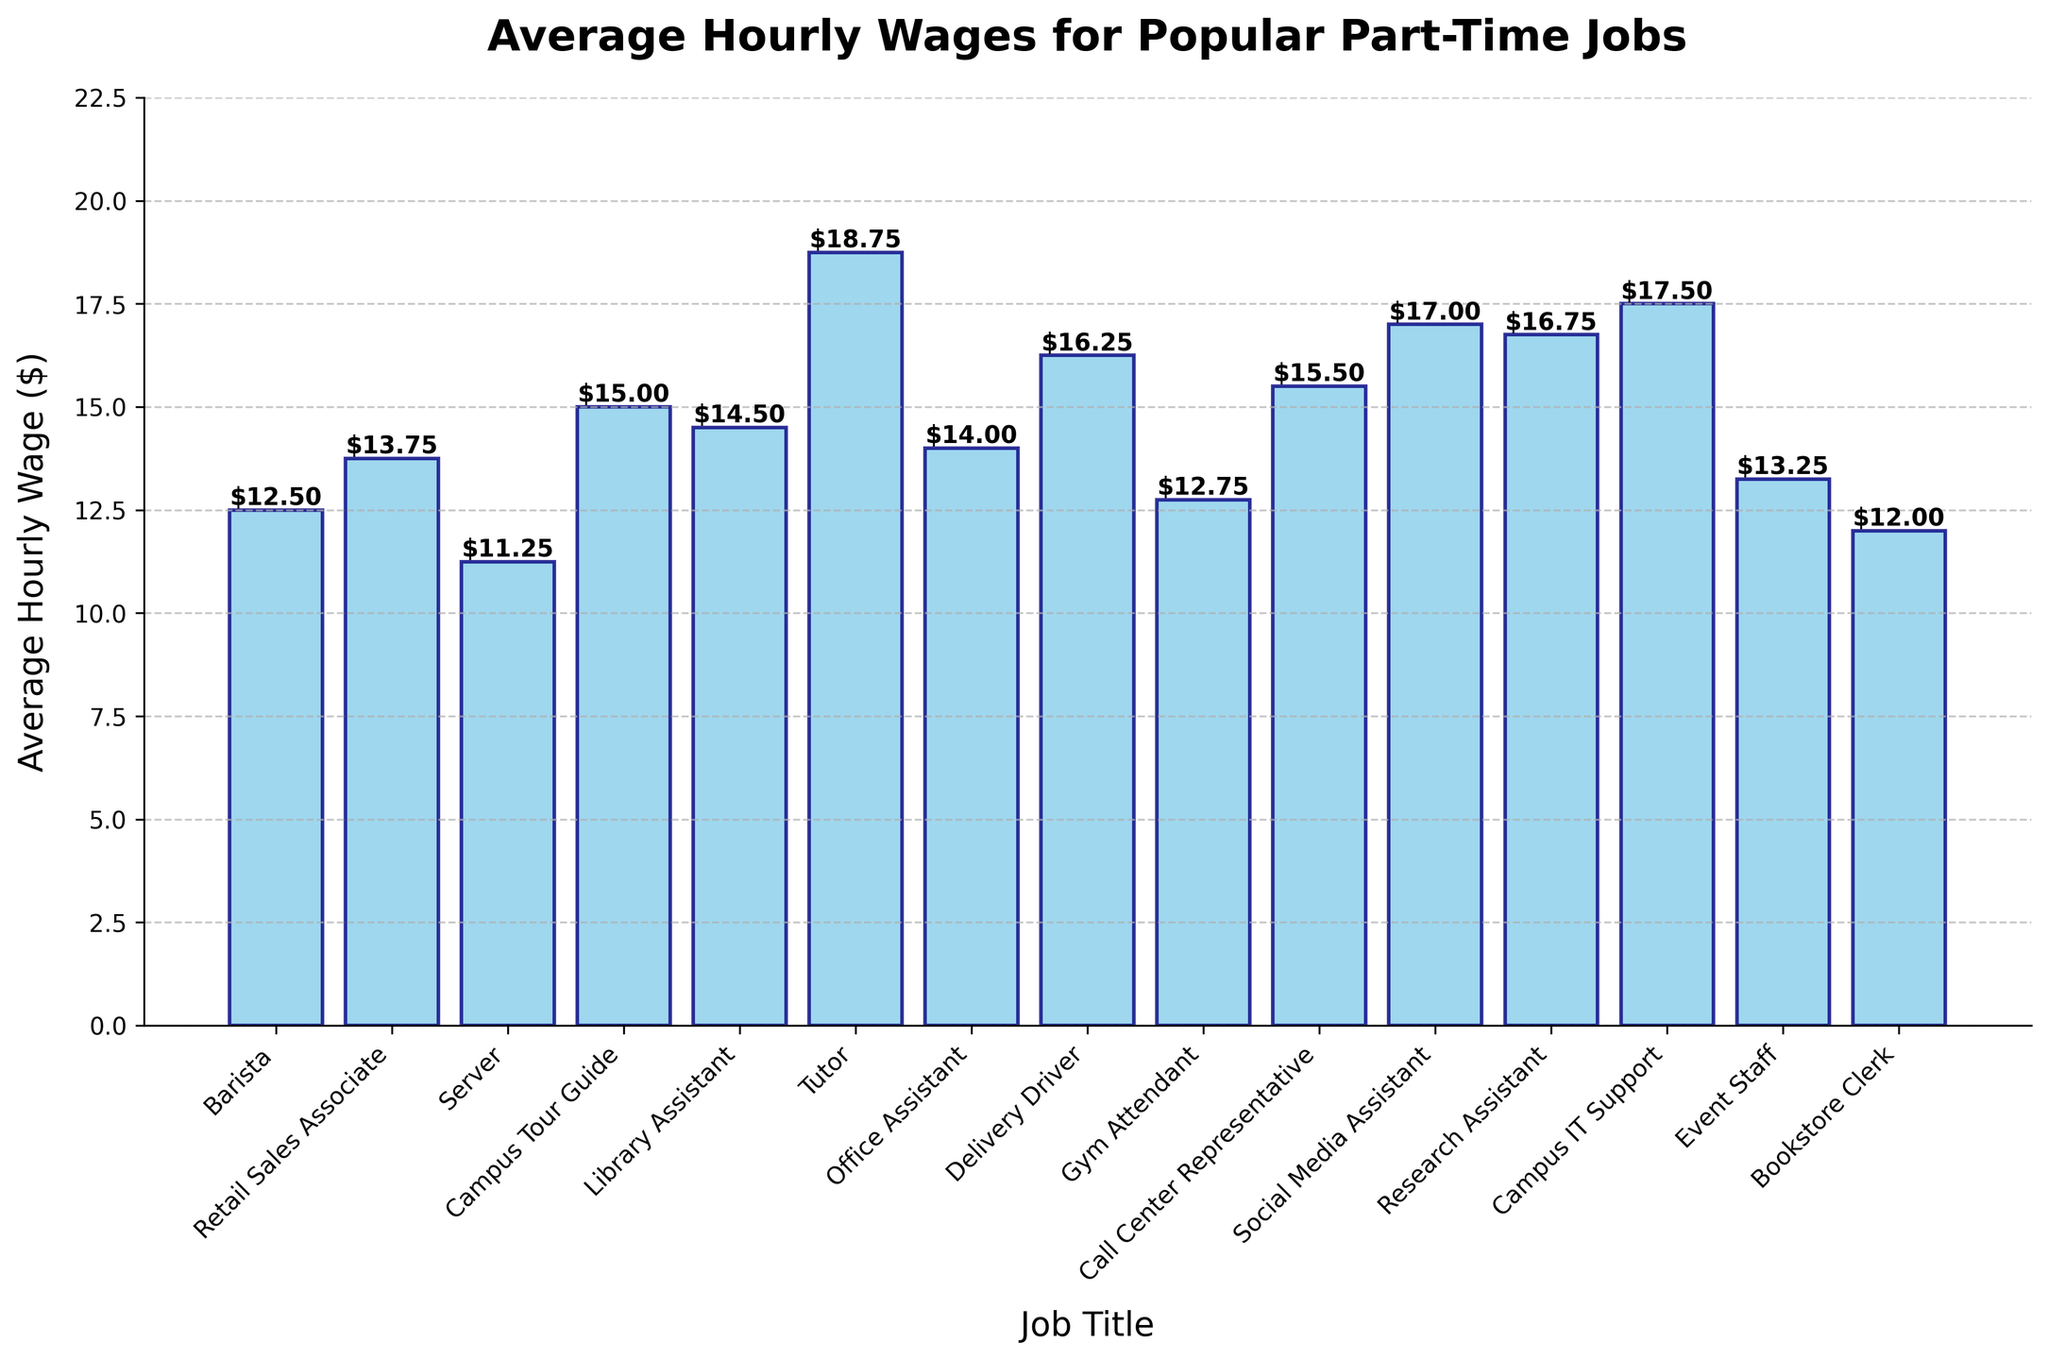Which job has the highest average hourly wage? The tallest bar represents the job with the highest hourly wage. In the chart, the tallest bar corresponds to the job "Tutor."
Answer: Tutor Which job has the lowest average hourly wage? The shortest bar represents the job with the lowest hourly wage. In the chart, the shortest bar corresponds to the job "Bookstore Clerk."
Answer: Bookstore Clerk What is the difference in hourly wage between the highest paying and the lowest paying jobs? The highest hourly wage is $18.75 (Tutor), and the lowest is $12.00 (Bookstore Clerk). The difference is calculated as $18.75 - $12.00.
Answer: $6.75 What is the total average hourly wage for the "Delivery Driver" and "Campus IT Support" jobs? The average hourly wage for the Delivery Driver is $16.25, and for the Campus IT Support is $17.50. The total is calculated as $16.25 + $17.50.
Answer: $33.75 Which job pays more per hour: "Library Assistant" or "Office Assistant"? Compare the heights of the bars for Library Assistant ($14.50) and Office Assistant ($14.00). The Library Assistant bar is taller.
Answer: Library Assistant How many jobs have an average hourly wage of $15.00 or more? Count the number of bars that have a height of $15.00 or above: Campus Tour Guide, Tutor, Delivery Driver, Call Center Representative, Social Media Assistant, Research Assistant, and Campus IT Support.
Answer: 7 jobs What is the average hourly wage for the jobs "Retail Sales Associate," "Server," and "Barista"? Calculate the average of $13.75 (Retail Sales Associate), $11.25 (Server), and $12.50 (Barista): ($13.75 + $11.25 + $12.50) / 3.
Answer: $12.50 Which job pays less per hour: "Gym Attendant" or "Event Staff"? Compare the heights of the bars for Gym Attendant ($12.75) and Event Staff ($13.25). The Gym Attendant bar is shorter.
Answer: Gym Attendant What's the average wage across all listed jobs? Sum all the wages and divide by the number of jobs. Sum = $12.50 + $13.75 + $11.25 + $15.00 + $14.50 + $18.75 + $14.00 + $16.25 + $12.75 + $15.50 + $17.00 + $16.75 + $17.50 + $13.25 + $12.00 = $221.75, and there are 15 jobs: $221.75 / 15 = $14.78.
Answer: $14.78 Which pair of jobs have the same average hourly wage? Only one pair of bars has the same height. "Library Assistant" and "Office Assistant" do not match exactly. Correctly identify pair based on available data, if any exist. As it's visually challenging, this needs a more careful eye on similar heights.
Answer: None How much more does a "Call Center Representative" earn compared to a "Retail Sales Associate"? The hourly wage for Call Center Representative is $15.50, and for Retail Sales Associate, it is $13.75. The difference is calculated as $15.50 - $13.75.
Answer: $1.75 